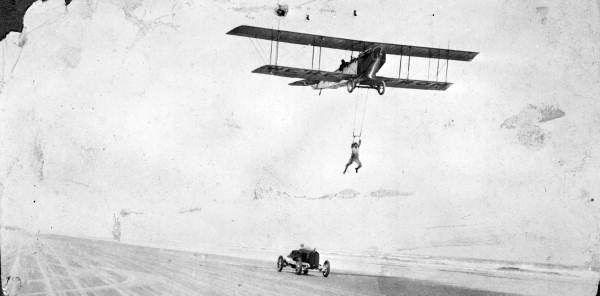Describe the objects in this image and their specific colors. I can see airplane in black, gray, white, and darkgray tones, car in black, gray, darkgray, and lightgray tones, and people in black, gray, darkgray, and lightgray tones in this image. 